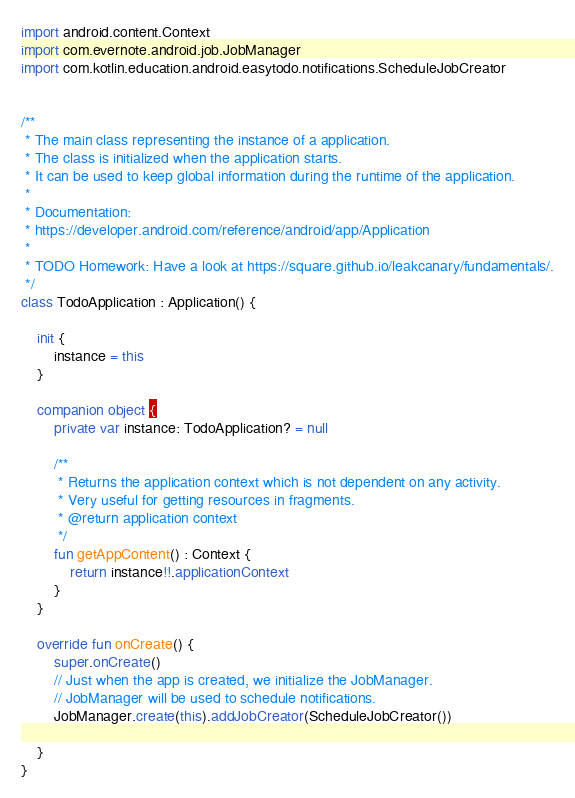<code> <loc_0><loc_0><loc_500><loc_500><_Kotlin_>import android.content.Context
import com.evernote.android.job.JobManager
import com.kotlin.education.android.easytodo.notifications.ScheduleJobCreator


/**
 * The main class representing the instance of a application.
 * The class is initialized when the application starts.
 * It can be used to keep global information during the runtime of the application.
 *
 * Documentation:
 * https://developer.android.com/reference/android/app/Application
 *
 * TODO Homework: Have a look at https://square.github.io/leakcanary/fundamentals/.
 */
class TodoApplication : Application() {

    init {
        instance = this
    }

    companion object {
        private var instance: TodoApplication? = null

        /**
         * Returns the application context which is not dependent on any activity.
         * Very useful for getting resources in fragments.
         * @return application context
         */
        fun getAppContent() : Context {
            return instance!!.applicationContext
        }
    }

    override fun onCreate() {
        super.onCreate()
        // Just when the app is created, we initialize the JobManager.
        // JobManager will be used to schedule notifications.
        JobManager.create(this).addJobCreator(ScheduleJobCreator())

    }
}</code> 